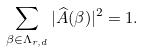<formula> <loc_0><loc_0><loc_500><loc_500>\sum _ { \beta \in \Lambda _ { r , d } } | \widehat { A } ( \beta ) | ^ { 2 } = 1 .</formula> 